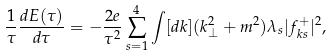Convert formula to latex. <formula><loc_0><loc_0><loc_500><loc_500>\frac { 1 } { \tau } \frac { d E ( \tau ) } { d \tau } = - \frac { 2 e } { \tau ^ { 2 } } \sum _ { s = 1 } ^ { 4 } \int [ d { k } ] ( { k } ^ { 2 } _ { \perp } + m ^ { 2 } ) \lambda _ { s } | f _ { { k } s } ^ { + } | ^ { 2 } ,</formula> 